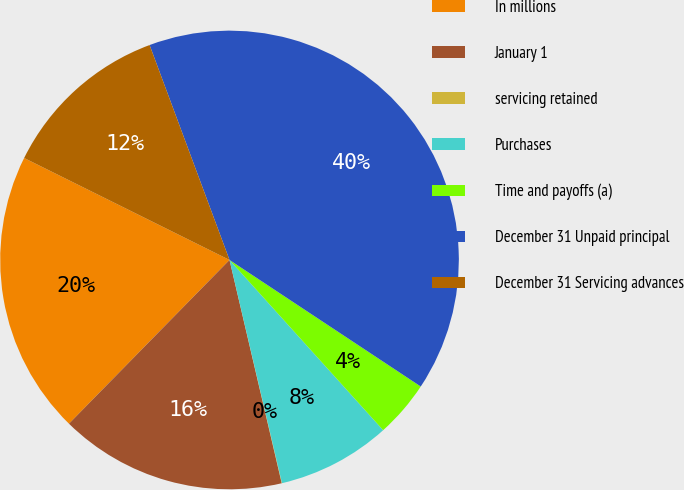<chart> <loc_0><loc_0><loc_500><loc_500><pie_chart><fcel>In millions<fcel>January 1<fcel>servicing retained<fcel>Purchases<fcel>Time and payoffs (a)<fcel>December 31 Unpaid principal<fcel>December 31 Servicing advances<nl><fcel>19.99%<fcel>16.0%<fcel>0.02%<fcel>8.01%<fcel>4.01%<fcel>39.97%<fcel>12.0%<nl></chart> 